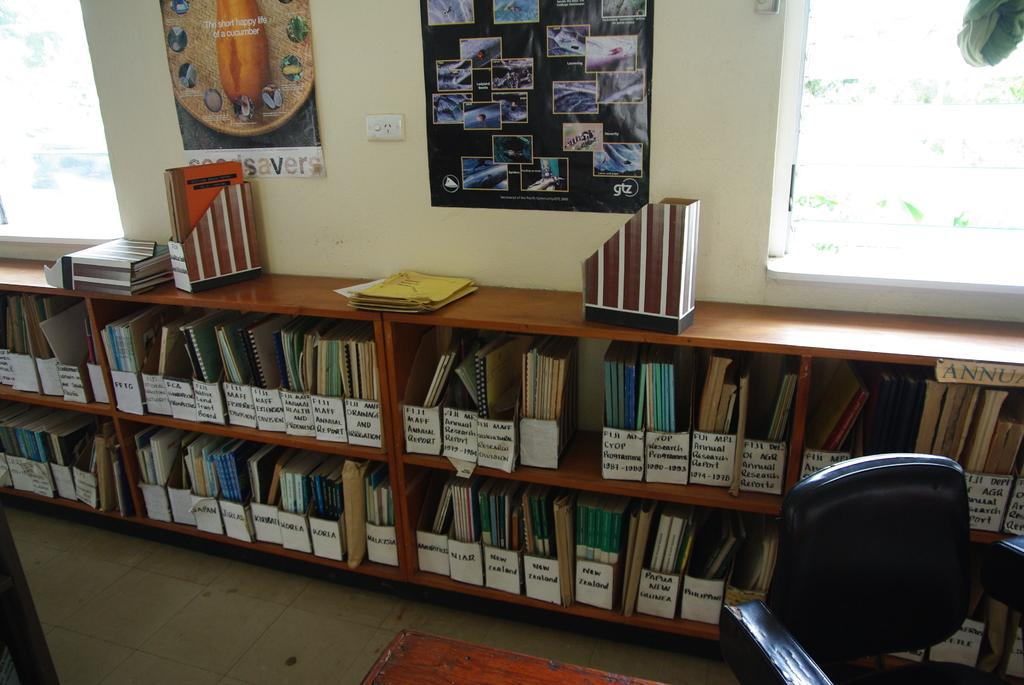<image>
Create a compact narrative representing the image presented. Reports labeled, annual, Korea, Japan, and others in folders on shelves in a room. 